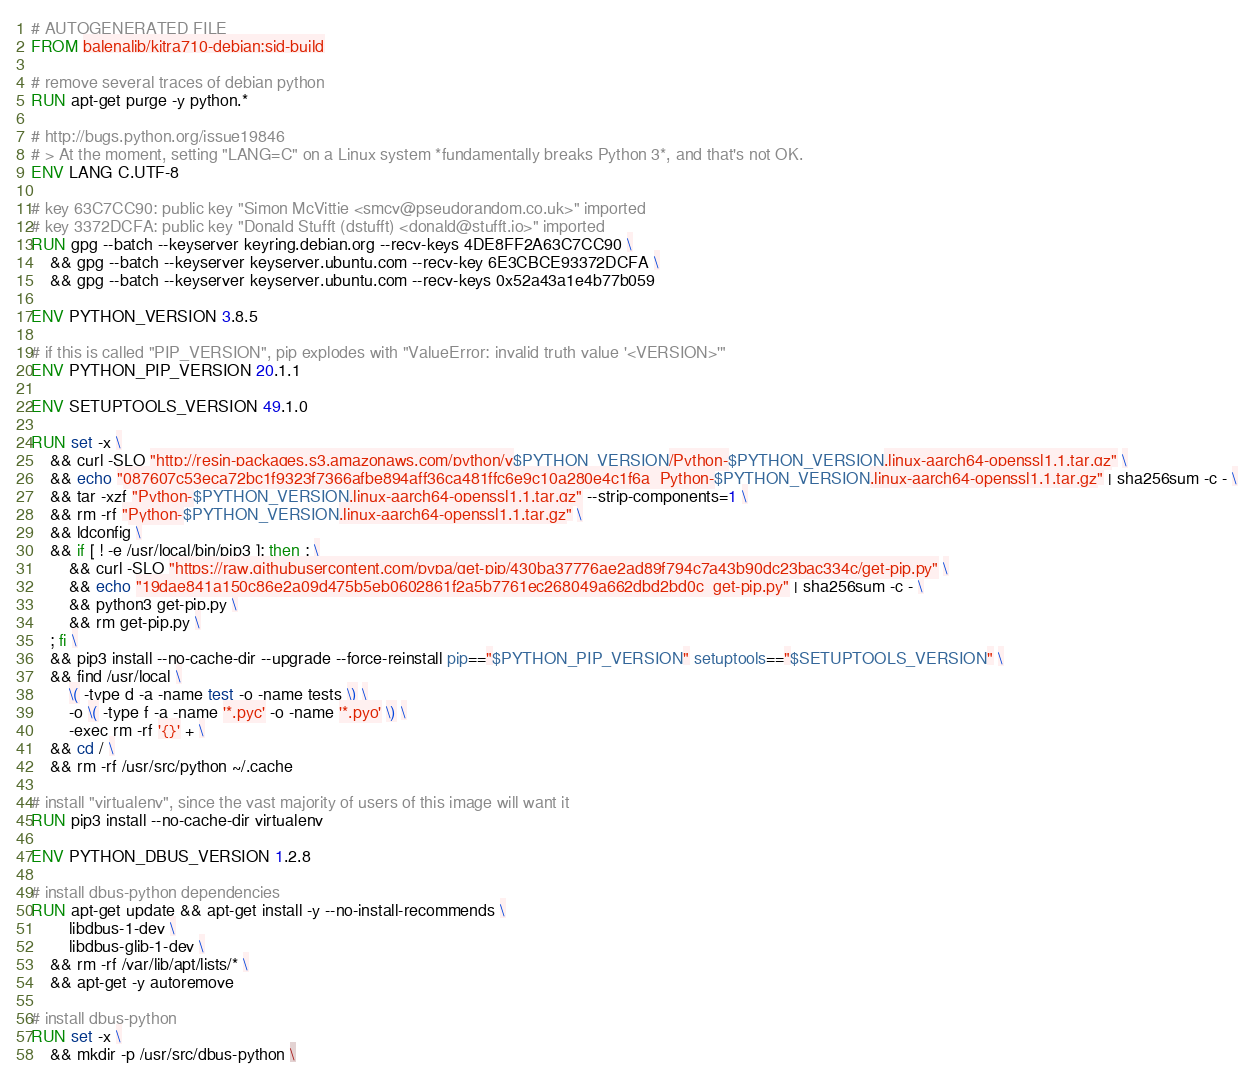<code> <loc_0><loc_0><loc_500><loc_500><_Dockerfile_># AUTOGENERATED FILE
FROM balenalib/kitra710-debian:sid-build

# remove several traces of debian python
RUN apt-get purge -y python.*

# http://bugs.python.org/issue19846
# > At the moment, setting "LANG=C" on a Linux system *fundamentally breaks Python 3*, and that's not OK.
ENV LANG C.UTF-8

# key 63C7CC90: public key "Simon McVittie <smcv@pseudorandom.co.uk>" imported
# key 3372DCFA: public key "Donald Stufft (dstufft) <donald@stufft.io>" imported
RUN gpg --batch --keyserver keyring.debian.org --recv-keys 4DE8FF2A63C7CC90 \
	&& gpg --batch --keyserver keyserver.ubuntu.com --recv-key 6E3CBCE93372DCFA \
	&& gpg --batch --keyserver keyserver.ubuntu.com --recv-keys 0x52a43a1e4b77b059

ENV PYTHON_VERSION 3.8.5

# if this is called "PIP_VERSION", pip explodes with "ValueError: invalid truth value '<VERSION>'"
ENV PYTHON_PIP_VERSION 20.1.1

ENV SETUPTOOLS_VERSION 49.1.0

RUN set -x \
	&& curl -SLO "http://resin-packages.s3.amazonaws.com/python/v$PYTHON_VERSION/Python-$PYTHON_VERSION.linux-aarch64-openssl1.1.tar.gz" \
	&& echo "087607c53eca72bc1f9323f7366afbe894aff36ca481ffc6e9c10a280e4c1f6a  Python-$PYTHON_VERSION.linux-aarch64-openssl1.1.tar.gz" | sha256sum -c - \
	&& tar -xzf "Python-$PYTHON_VERSION.linux-aarch64-openssl1.1.tar.gz" --strip-components=1 \
	&& rm -rf "Python-$PYTHON_VERSION.linux-aarch64-openssl1.1.tar.gz" \
	&& ldconfig \
	&& if [ ! -e /usr/local/bin/pip3 ]; then : \
		&& curl -SLO "https://raw.githubusercontent.com/pypa/get-pip/430ba37776ae2ad89f794c7a43b90dc23bac334c/get-pip.py" \
		&& echo "19dae841a150c86e2a09d475b5eb0602861f2a5b7761ec268049a662dbd2bd0c  get-pip.py" | sha256sum -c - \
		&& python3 get-pip.py \
		&& rm get-pip.py \
	; fi \
	&& pip3 install --no-cache-dir --upgrade --force-reinstall pip=="$PYTHON_PIP_VERSION" setuptools=="$SETUPTOOLS_VERSION" \
	&& find /usr/local \
		\( -type d -a -name test -o -name tests \) \
		-o \( -type f -a -name '*.pyc' -o -name '*.pyo' \) \
		-exec rm -rf '{}' + \
	&& cd / \
	&& rm -rf /usr/src/python ~/.cache

# install "virtualenv", since the vast majority of users of this image will want it
RUN pip3 install --no-cache-dir virtualenv

ENV PYTHON_DBUS_VERSION 1.2.8

# install dbus-python dependencies 
RUN apt-get update && apt-get install -y --no-install-recommends \
		libdbus-1-dev \
		libdbus-glib-1-dev \
	&& rm -rf /var/lib/apt/lists/* \
	&& apt-get -y autoremove

# install dbus-python
RUN set -x \
	&& mkdir -p /usr/src/dbus-python \</code> 